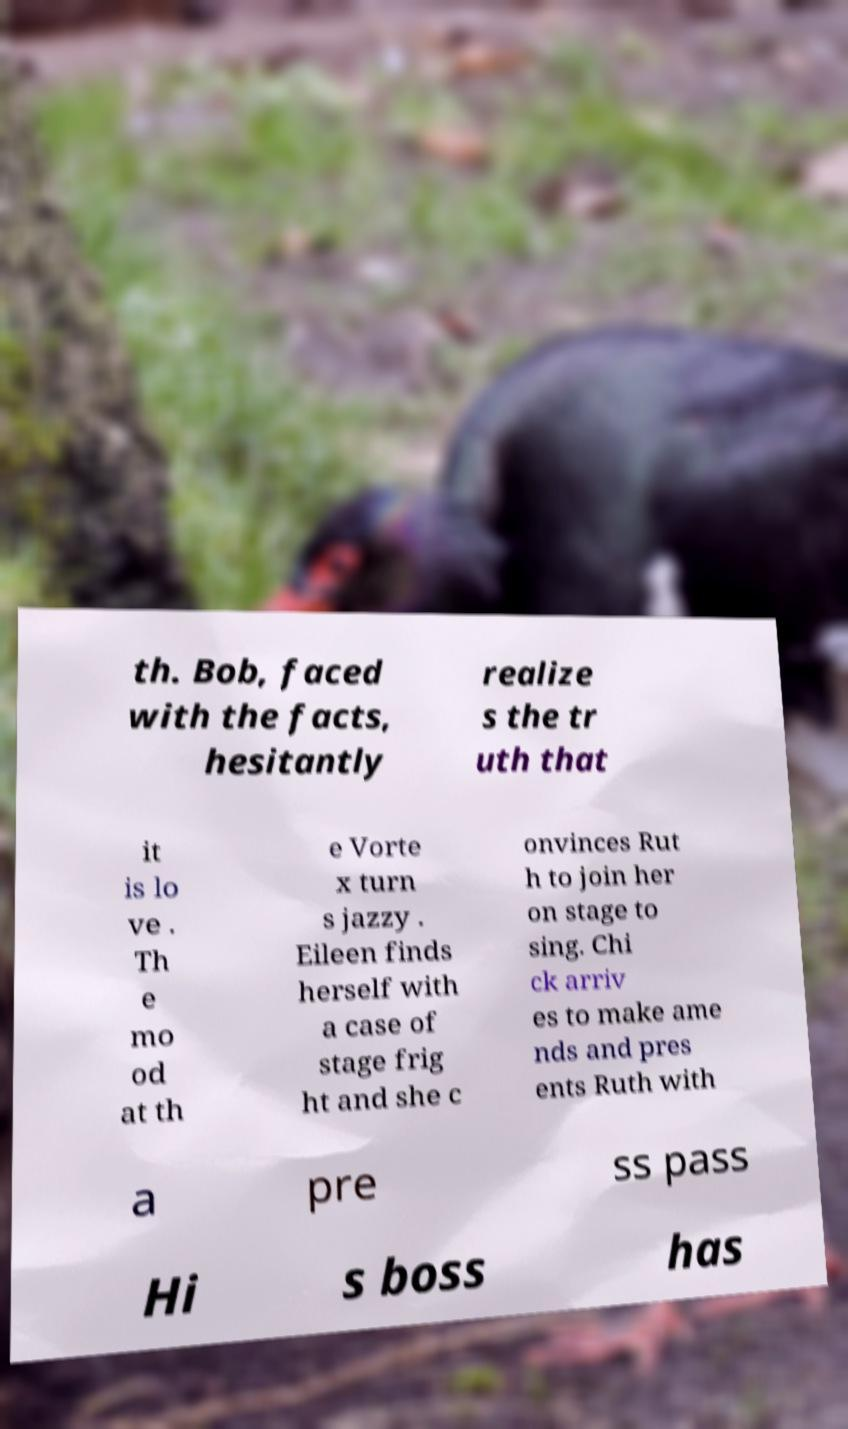Can you accurately transcribe the text from the provided image for me? th. Bob, faced with the facts, hesitantly realize s the tr uth that it is lo ve . Th e mo od at th e Vorte x turn s jazzy . Eileen finds herself with a case of stage frig ht and she c onvinces Rut h to join her on stage to sing. Chi ck arriv es to make ame nds and pres ents Ruth with a pre ss pass Hi s boss has 